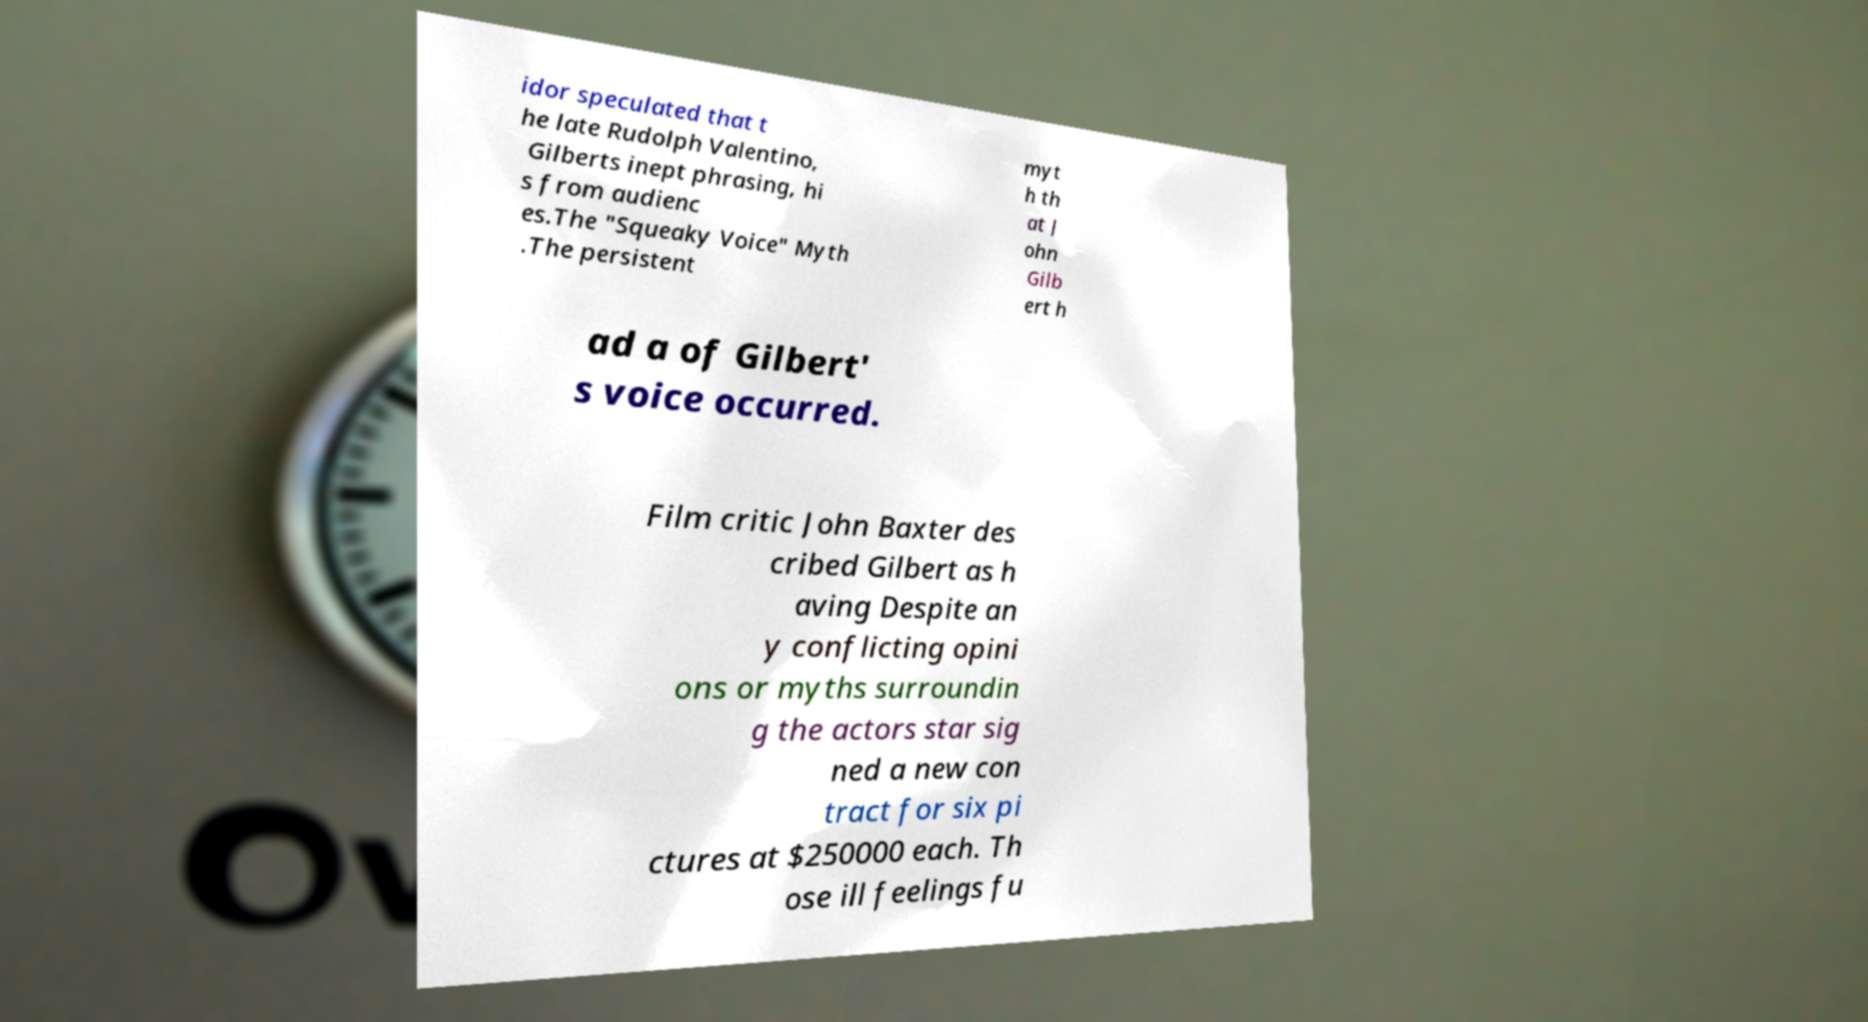Could you extract and type out the text from this image? idor speculated that t he late Rudolph Valentino, Gilberts inept phrasing, hi s from audienc es.The "Squeaky Voice" Myth .The persistent myt h th at J ohn Gilb ert h ad a of Gilbert' s voice occurred. Film critic John Baxter des cribed Gilbert as h aving Despite an y conflicting opini ons or myths surroundin g the actors star sig ned a new con tract for six pi ctures at $250000 each. Th ose ill feelings fu 